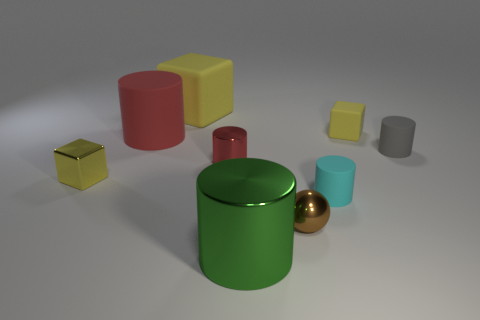How many yellow blocks must be subtracted to get 1 yellow blocks? 2 Subtract all green cylinders. How many cylinders are left? 4 Subtract all cyan cylinders. How many cylinders are left? 4 Subtract all green cylinders. Subtract all gray cubes. How many cylinders are left? 4 Add 1 small purple metal objects. How many objects exist? 10 Subtract all cubes. How many objects are left? 6 Add 6 big yellow matte blocks. How many big yellow matte blocks exist? 7 Subtract 3 yellow cubes. How many objects are left? 6 Subtract all tiny red matte balls. Subtract all big metallic cylinders. How many objects are left? 8 Add 2 large yellow rubber cubes. How many large yellow rubber cubes are left? 3 